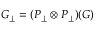Convert formula to latex. <formula><loc_0><loc_0><loc_500><loc_500>G _ { \perp } = ( P _ { \perp } \otimes P _ { \perp } ) ( G )</formula> 